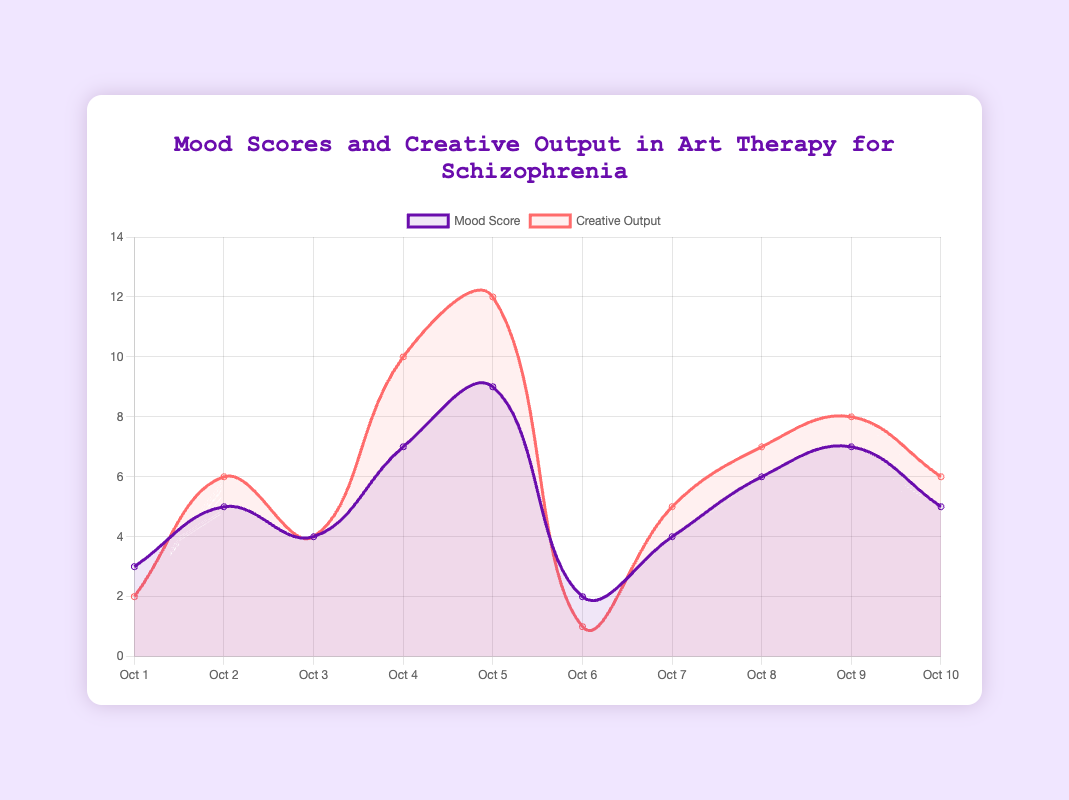Which day had the highest mood score? To determine the day with the highest mood score, look for the peak in the "Mood Score" line on the plot. The highest mood score is 9 on October 5th.
Answer: October 5 Which medium was used on the day with the lowest creative output? Find the day with the lowest point in the "Creative Output" line, which is a score of 1. This occurs on October 6th. The medium used on October 6th was Sketching.
Answer: Sketching What is the average mood score over the 10 days? Sum the mood scores (3 + 5 + 4 + 7 + 9 + 2 + 4 + 6 + 7 + 5) = 52. Then, divide by the number of days, which is 10. The average mood score is 52/10 = 5.2.
Answer: 5.2 On which dates did the mood score and creative output both increase compared to the previous day? Compare each day's mood score and creative output with the previous day. On October 2 and October 8, both mood score and creative output increased compared to the previous day.
Answer: October 2, October 8 How many days had a mood score greater than 6? Identify the points where the "Mood Score" line is above 6. These occur on October 4 (7), October 5 (9), October 8 (6), and October 9 (7). Therefore, there are 4 days with mood scores greater than 6.
Answer: 4 Which day had both the mood score and creative output exactly at 6? Find the points where both the "Mood Score" and "Creative Output" lines intersect at the value 6. This occurs on October 2 and October 10.
Answer: October 2, October 10 What is the difference between the maximum creative output and the minimum mood score? The maximum creative output is 12 (October 5), and the minimum mood score is 2 (October 6). The difference is 12 - 2 = 10.
Answer: 10 Which day had the mood score decrease the most compared to the previous day? Look at the "Mood Score" line for the largest drop between consecutive days. The biggest decrease is from 9 (October 5) to 2 (October 6), a drop of 7.
Answer: October 6 What is the total creative output for the week of October 1 to October 7? Sum the creative outputs from October 1 to October 7 (2 + 6 + 4 + 10 + 12 + 1 + 5): 2 + 6 + 4 + 10 + 12 + 1 + 5 = 40.
Answer: 40 Visual question: What color represents the creative output line on the plot? The description states that the "Creative Output" line is represented by red color.
Answer: Red 